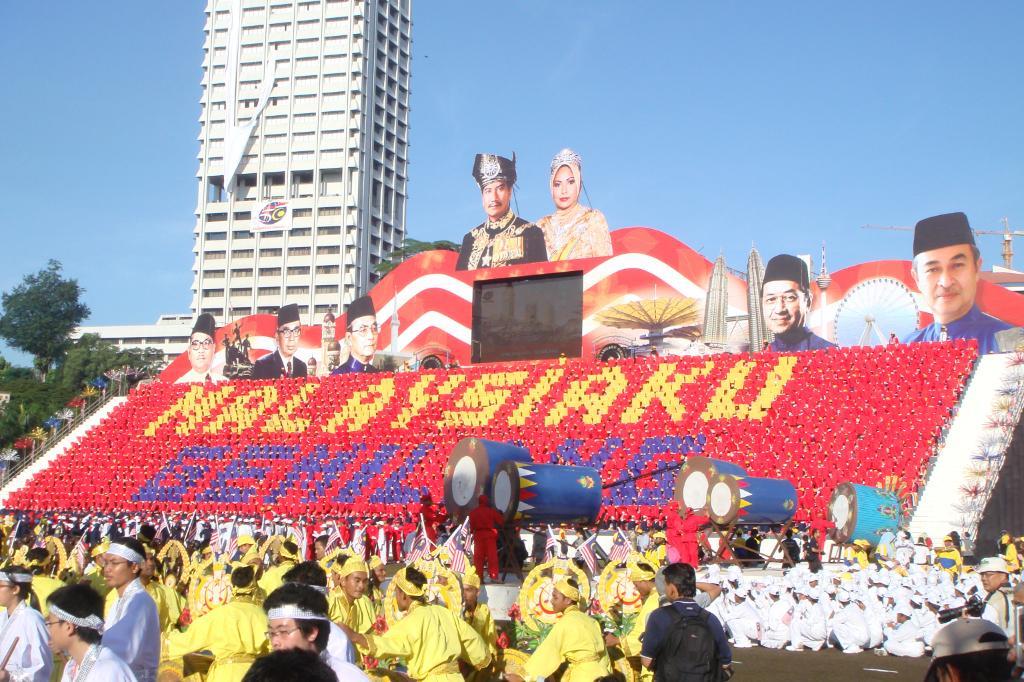Can you describe this image briefly? In this picture we can see a group of people on the ground, flags, posters, building, trees and some objects and in the background we can see the sky. 